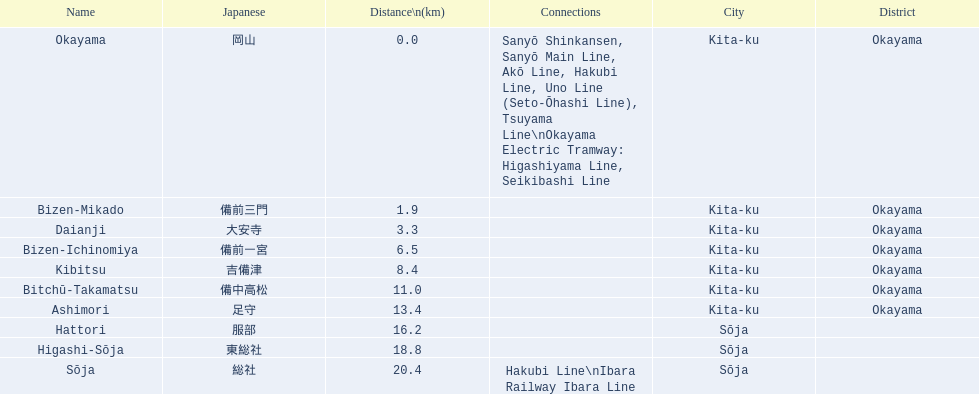Which has the most distance, hattori or kibitsu? Hattori. 